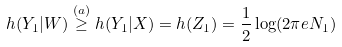Convert formula to latex. <formula><loc_0><loc_0><loc_500><loc_500>h ( Y _ { 1 } | W ) \stackrel { ( a ) } \geq h ( Y _ { 1 } | X ) = h ( Z _ { 1 } ) = \frac { 1 } { 2 } \log ( 2 \pi e N _ { 1 } )</formula> 